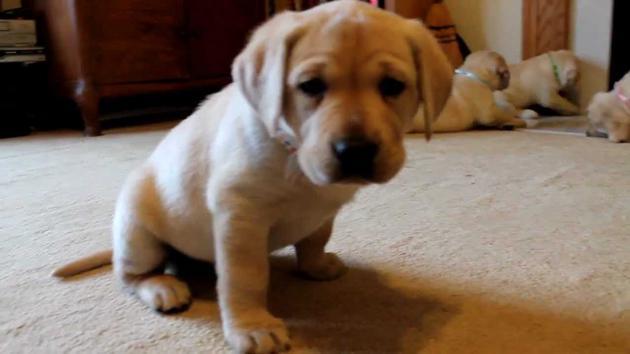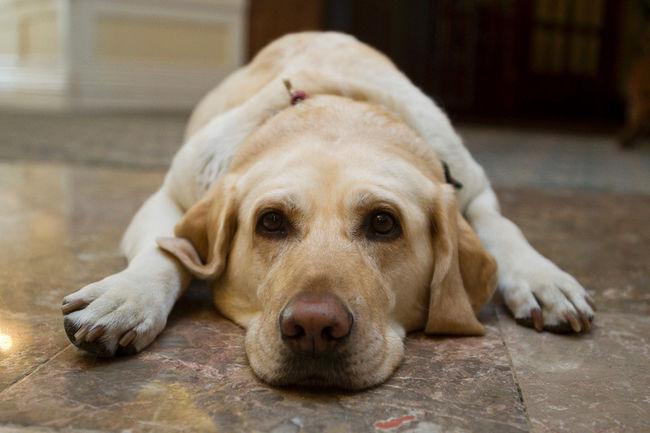The first image is the image on the left, the second image is the image on the right. Examine the images to the left and right. Is the description "A dog is carrying something in its mouth." accurate? Answer yes or no. No. The first image is the image on the left, the second image is the image on the right. For the images displayed, is the sentence "In one image in each pair an upright dog has something in its mouth." factually correct? Answer yes or no. No. 